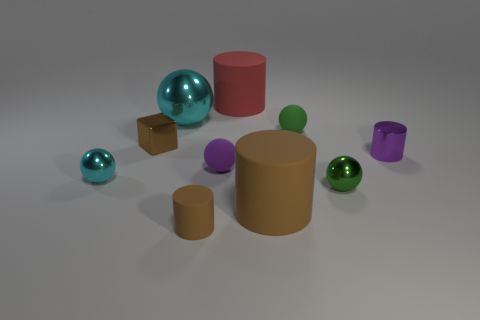Is the material of the purple ball the same as the ball that is on the right side of the green rubber object?
Make the answer very short. No. There is a tiny ball that is behind the small cylinder on the right side of the small brown rubber cylinder; what is its material?
Provide a short and direct response. Rubber. Are there more green matte things behind the big brown cylinder than gray matte cylinders?
Your response must be concise. Yes. Are any brown metal cylinders visible?
Offer a terse response. No. The metal thing on the left side of the small brown cube is what color?
Ensure brevity in your answer.  Cyan. There is a purple object that is the same size as the purple cylinder; what is its material?
Provide a succinct answer. Rubber. The ball that is both behind the purple cylinder and left of the purple matte ball is what color?
Your answer should be compact. Cyan. How many objects are cyan metallic spheres that are behind the small metal cylinder or cyan rubber cylinders?
Your answer should be compact. 1. What number of other things are the same color as the large metallic thing?
Provide a short and direct response. 1. Are there an equal number of small brown rubber objects on the left side of the brown cube and red rubber cylinders?
Your answer should be compact. No. 